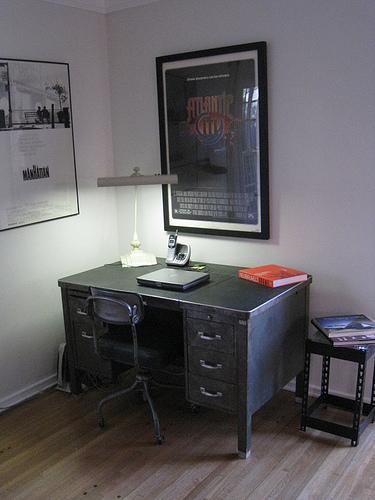Is the lamp sitting on the desk on or off?
Short answer required. On. Is this room messy?
Be succinct. No. Is the poster on the right framed in glass?
Answer briefly. Yes. 